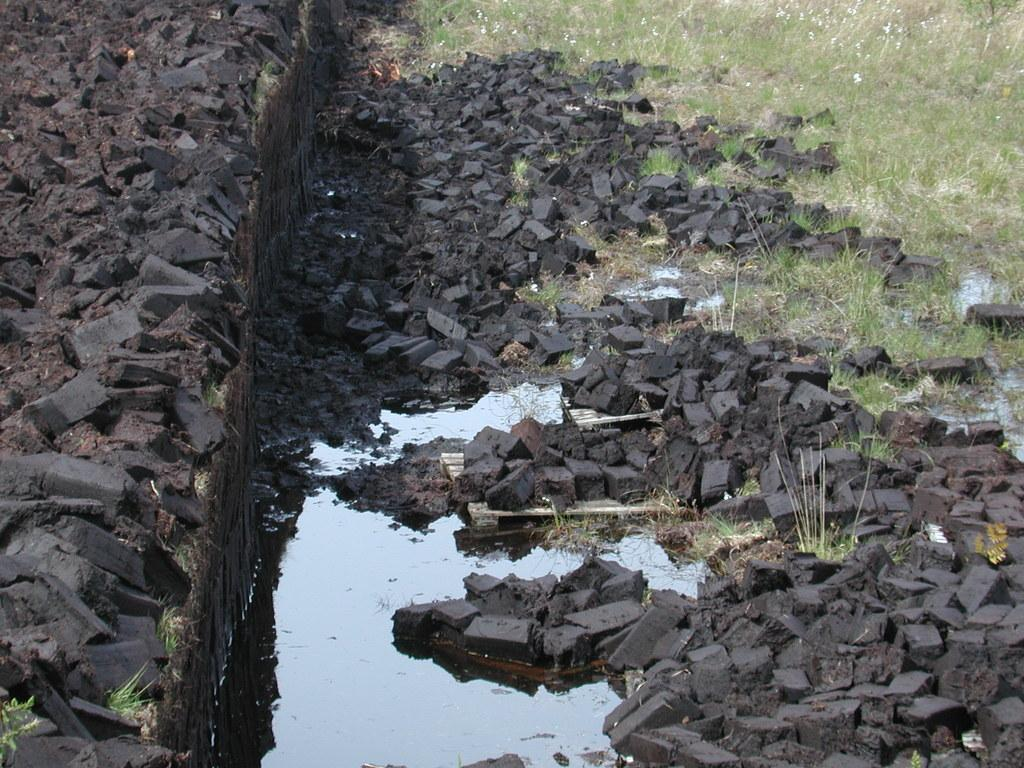What type of material is covering the ground in the image? There are black stones on the ground in the image. What else can be seen on the ground in the image? There is water and grass visible on the ground in the image. Where is the throne located in the image? There is no throne present in the image. Can you describe the muscles of the person in the image? There is no person present in the image, so it is not possible to describe their muscles. 